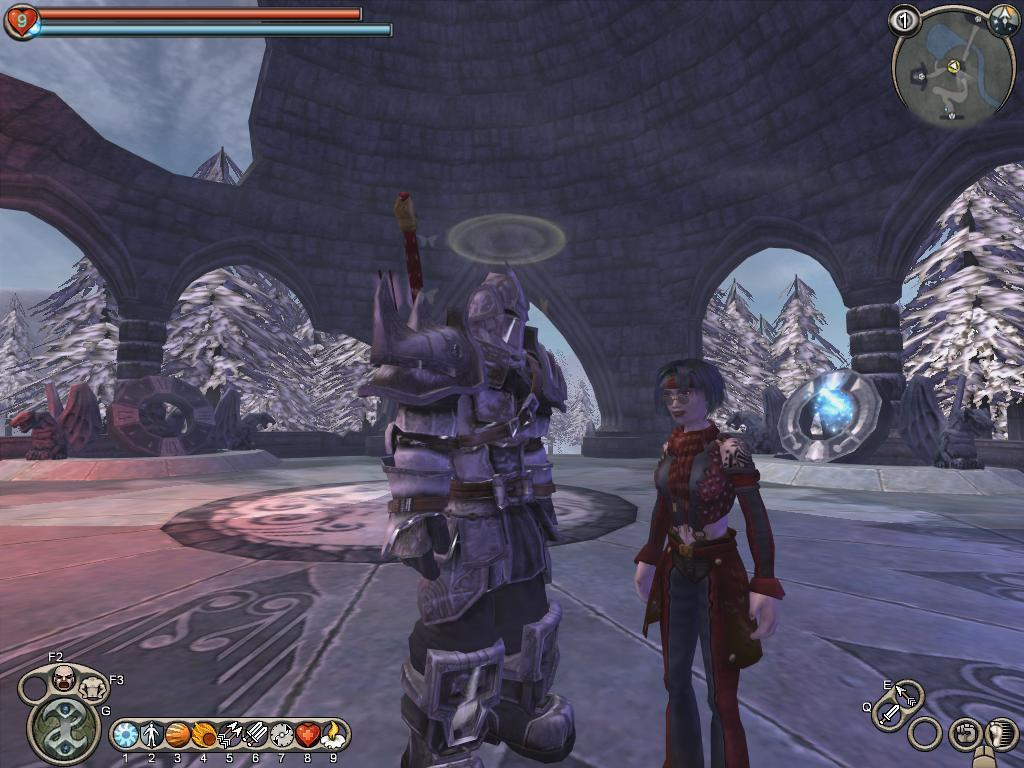What type of image is being described? The image is animated. How many people are in the image? There are two persons standing in the image. Where are the persons standing? The persons are standing on the floor. What can be seen in the background of the image? There is a wall and trees in the background of the image. What type of pain is the person on the left experiencing in the image? There is no indication of pain or any emotions in the image; it simply two persons are standing on the floor. --- Facts: 1. There is a car in the image. 2. The car is red. 3. The car has four wheels. 4. There is a road in the image. 5. The road is paved. Absurd Topics: ocean, bird, sand Conversation: What is the main subject of the image? The main subject of the image is a car. What color is the car? The car is red. How many wheels does the car have? The car has four wheels. What type of surface is the car on? There is a road in the image, and it is paved. Reasoning: Let's think step by step in order to produce the conversation. We start by identifying the main subject of the image, which is the car. Then, we describe the car's color and the number of wheels it has. Finally, we focus on the surface the car is on, which is a paved road. Each question is designed to elicit a specific detail about the image that is known from the provided facts. Absurd Question/Answer: Can you see any birds flying over the ocean in the image? There is no ocean or birds present in the image; it features a red car on a paved road. 